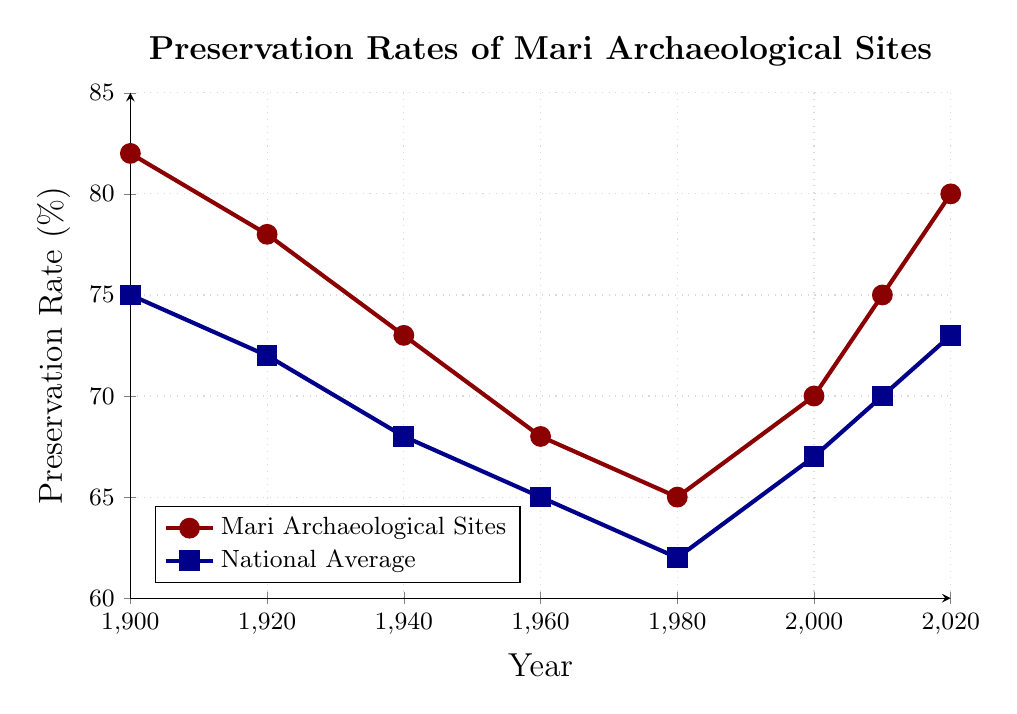What is the preservation rate for Mari Archaeological Sites in 1940? The preservation rate for Mari Archaeological Sites in 1940 can be directly read from the red line at the year 1940.
Answer: 73% How does the preservation rate in 2000 compare between Mari Archaeological Sites and the National Average? In 2000, the preservation rate for Mari Archaeological Sites is shown by the red mark, while the national average preservation rate is shown by the blue mark. By comparing these values on the chart, Mari Archaeological Sites have a higher preservation rate.
Answer: 70% for Mari, 67% for National What is the trend of the preservation rate for Mari Archaeological Sites from 1960 to 2020? To identify the trend, observe the red line from 1960 to 2020. The preservation rate decreases from 1960 to 1980, increases from 1980 to 2020.
Answer: Decreasing from 1960 to 1980, increasing from 1980 to 2020 Which year did Mari Archaeological Sites have the lowest preservation rate? Locate the lowest point on the red line within the chart to find the year. The red line reaches its lowest point in 1980.
Answer: 1980 What is the difference in the preservation rate between Mari Archaeological Sites and the National Average in 1900? Subtract the National Average preservation rate (blue mark) from the Mari Archaeological Sites preservation rate (red mark) in 1900.
Answer: 82% - 75% = 7% In which years do Mari Archaeological Sites and the National Average preservation rates intersect? Look at the chart for intersections between the red and blue lines. There are no years where the lines intersect.
Answer: No intersection What is the average preservation rate of Mari Archaeological Sites between 1900 and 2020? Add all the preservation rates for Mari Archaeological Sites (82, 78, 73, 68, 65, 70, 75, 80) and divide by the number of years (8).
Answer: (82 + 78 + 73 + 68 + 65 + 70 + 75 + 80) / 8 = 73.875 How did the preservation rate change for Mari Archaeological Sites from 2000 to 2010? Observe the red line between 2000 and 2010. The preservation rate increased. Subtract the 2000 value from the 2010 value.
Answer: 75% - 70% = 5% increase Compare the changes in preservation rates between 1920 and 1960 for both Mari and National Average. For Mari, the rate goes from 78% to 68%. For National, the rate goes from 72% to 65%. Calculate the differences for both.
Answer: Mari: 10% decrease, National: 7% decrease Which series has a higher preservation rate more often throughout the years, Mari Archaeological Sites or the National Average? Compare red and blue lines at each given year. The red line (Mari) is higher than the blue line (National) in each year.
Answer: Mari Archaeological Sites 